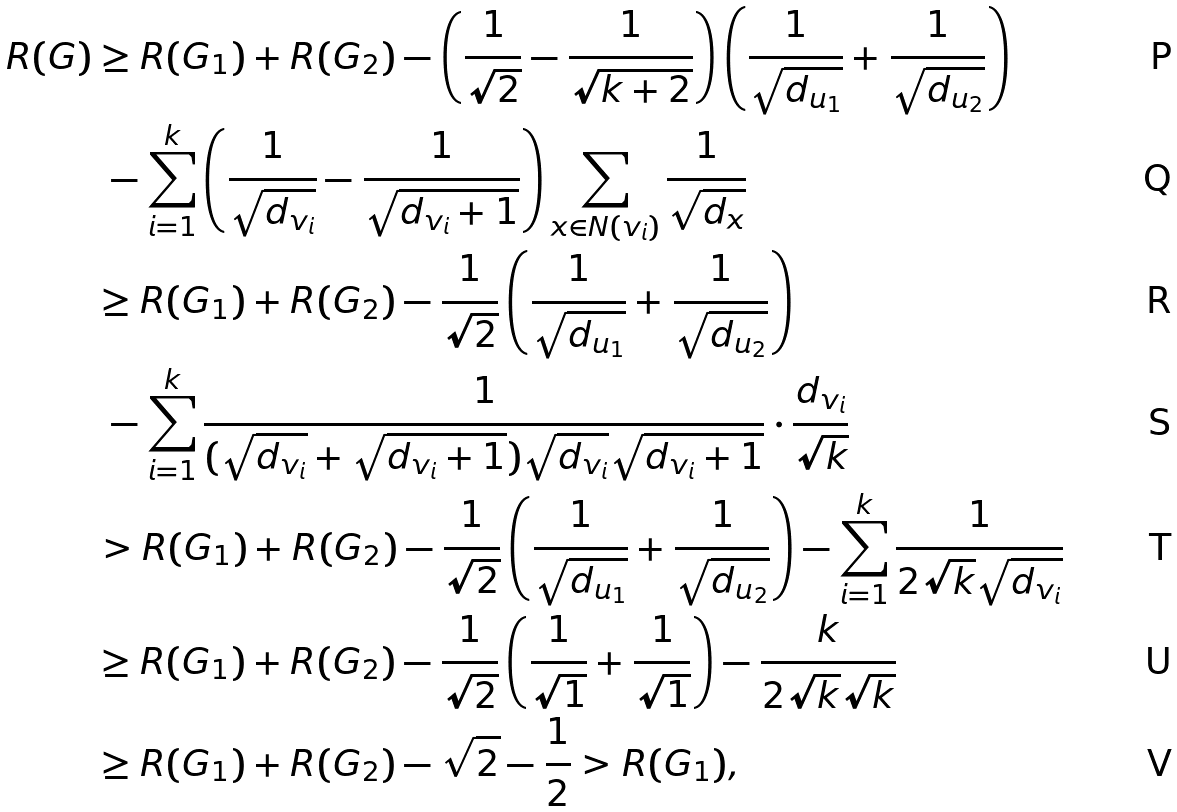<formula> <loc_0><loc_0><loc_500><loc_500>R ( G ) & \geq R ( G _ { 1 } ) + R ( G _ { 2 } ) - \left ( \frac { 1 } { \sqrt { 2 } } - \frac { 1 } { \sqrt { k + 2 } } \right ) \left ( \frac { 1 } { \sqrt { d _ { u _ { 1 } } } } + \frac { 1 } { \sqrt { d _ { u _ { 2 } } } } \right ) \\ & \ - \sum _ { i = 1 } ^ { k } \left ( \frac { 1 } { \sqrt { d _ { v _ { i } } } } - \frac { 1 } { \sqrt { d _ { v _ { i } } + 1 } } \right ) \sum _ { x \in N ( v _ { i } ) } \frac { 1 } { \sqrt { d _ { x } } } \\ & \geq R ( G _ { 1 } ) + R ( G _ { 2 } ) - \frac { 1 } { \sqrt { 2 } } \left ( \frac { 1 } { \sqrt { d _ { u _ { 1 } } } } + \frac { 1 } { \sqrt { d _ { u _ { 2 } } } } \right ) \\ & \ - \sum _ { i = 1 } ^ { k } \frac { 1 } { ( \sqrt { d _ { v _ { i } } } + \sqrt { d _ { v _ { i } } + 1 } ) \sqrt { d _ { v _ { i } } } \sqrt { d _ { v _ { i } } + 1 } } \cdot \frac { d _ { v _ { i } } } { \sqrt { k } } \\ & > R ( G _ { 1 } ) + R ( G _ { 2 } ) - \frac { 1 } { \sqrt { 2 } } \left ( \frac { 1 } { \sqrt { d _ { u _ { 1 } } } } + \frac { 1 } { \sqrt { d _ { u _ { 2 } } } } \right ) - \sum _ { i = 1 } ^ { k } \frac { 1 } { 2 \sqrt { k } \sqrt { d _ { v _ { i } } } } \\ & \geq R ( G _ { 1 } ) + R ( G _ { 2 } ) - \frac { 1 } { \sqrt { 2 } } \left ( \frac { 1 } { \sqrt { 1 } } + \frac { 1 } { \sqrt { 1 } } \right ) - \frac { k } { 2 \sqrt { k } \sqrt { k } } \\ & \geq R ( G _ { 1 } ) + R ( G _ { 2 } ) - \sqrt { 2 } - \frac { 1 } { 2 } > R ( G _ { 1 } ) ,</formula> 